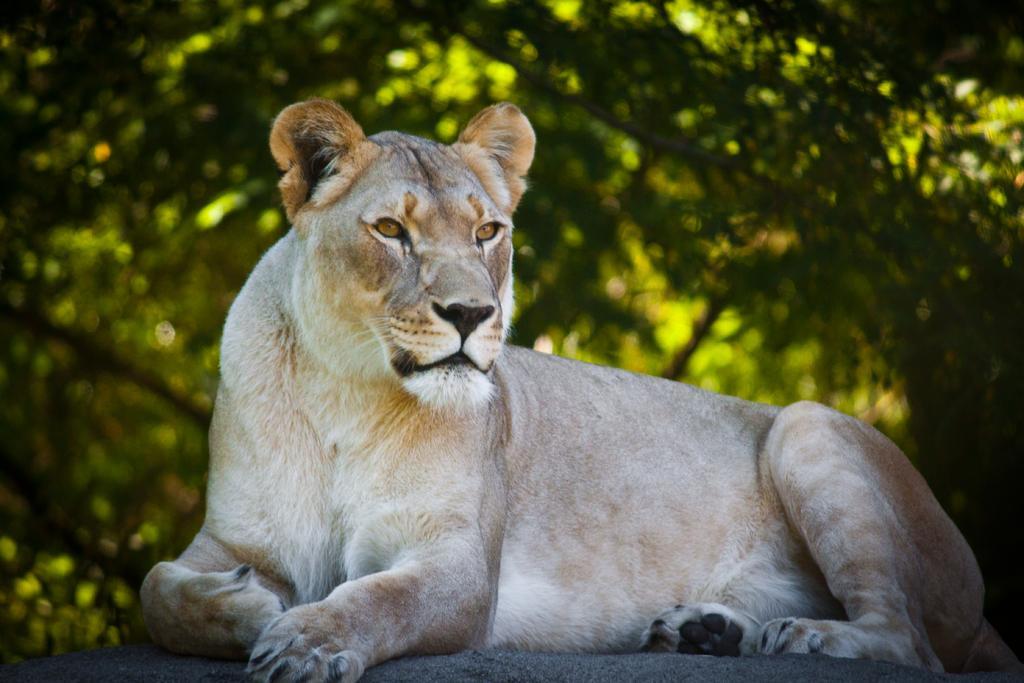Describe this image in one or two sentences. In this image, there is a lion looking at something. In the background, image is blurred. 